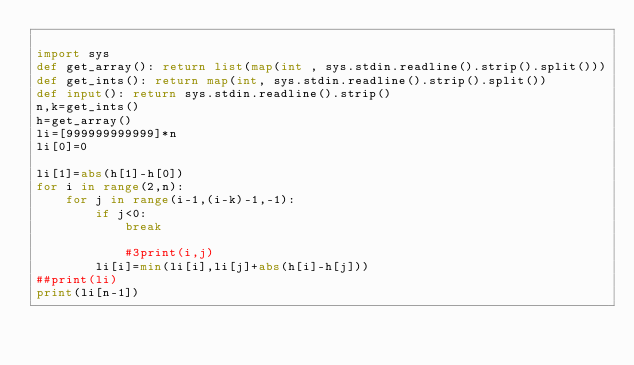Convert code to text. <code><loc_0><loc_0><loc_500><loc_500><_Python_>
import sys
def get_array(): return list(map(int , sys.stdin.readline().strip().split()))
def get_ints(): return map(int, sys.stdin.readline().strip().split())
def input(): return sys.stdin.readline().strip()
n,k=get_ints()
h=get_array()
li=[999999999999]*n
li[0]=0

li[1]=abs(h[1]-h[0])
for i in range(2,n):
    for j in range(i-1,(i-k)-1,-1):
        if j<0:
            break

            #3print(i,j)
        li[i]=min(li[i],li[j]+abs(h[i]-h[j]))
##print(li)
print(li[n-1])
</code> 